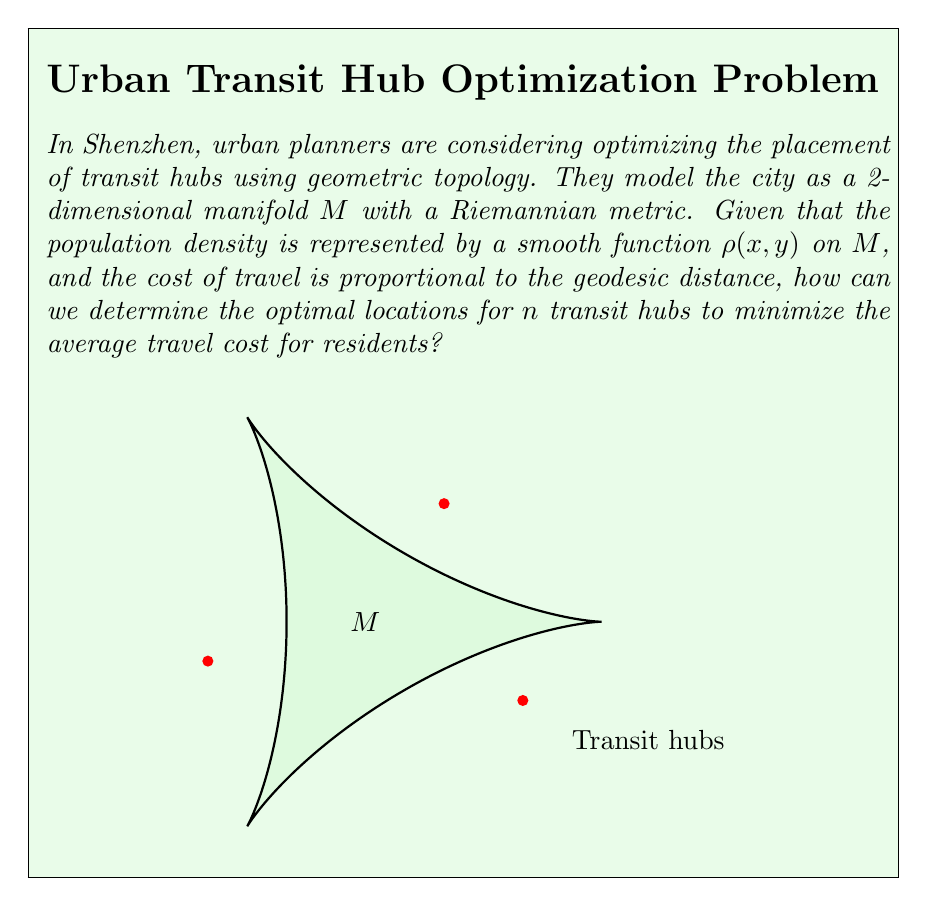Could you help me with this problem? To solve this problem, we can use the concept of geodesic Voronoi diagrams on manifolds. Here's a step-by-step approach:

1) First, we need to understand that the optimal placement of transit hubs is equivalent to minimizing the following functional:

   $$E(x_1, ..., x_n) = \int_M \min_{i=1,...,n} d_g(x, x_i)^2 \rho(x) dA$$

   where $x_1, ..., x_n$ are the locations of the $n$ transit hubs, $d_g(x, x_i)$ is the geodesic distance between a point $x$ on the manifold and the $i$-th hub, and $dA$ is the area element on $M$.

2) This problem is a generalization of the $k$-means clustering problem to Riemannian manifolds.

3) To solve this, we can use an iterative algorithm similar to Lloyd's algorithm:

   a) Start with an initial guess for the hub locations $x_1, ..., x_n$.
   
   b) Compute the geodesic Voronoi diagram of these points on $M$.
   
   c) For each Voronoi cell $V_i$, compute its weighted centroid:
      
      $$c_i = \frac{\int_{V_i} x \rho(x) dA}{\int_{V_i} \rho(x) dA}$$

   d) Move each hub $x_i$ to the centroid $c_i$ of its Voronoi cell.
   
   e) Repeat steps b-d until convergence.

4) The computation of geodesic distances and Voronoi diagrams on the manifold can be done using discrete approximations, such as the fast marching method on triangulated surfaces.

5) The population density function $\rho(x,y)$ acts as a weighting factor, ensuring that areas with higher population density have a stronger influence on hub placement.

6) Convergence can be determined by monitoring the change in hub positions or the value of the functional $E$ between iterations.

7) The final positions of the hubs after convergence represent the optimal locations that minimize the average travel cost for residents.
Answer: Iterative optimization using geodesic Voronoi diagrams and weighted centroids. 